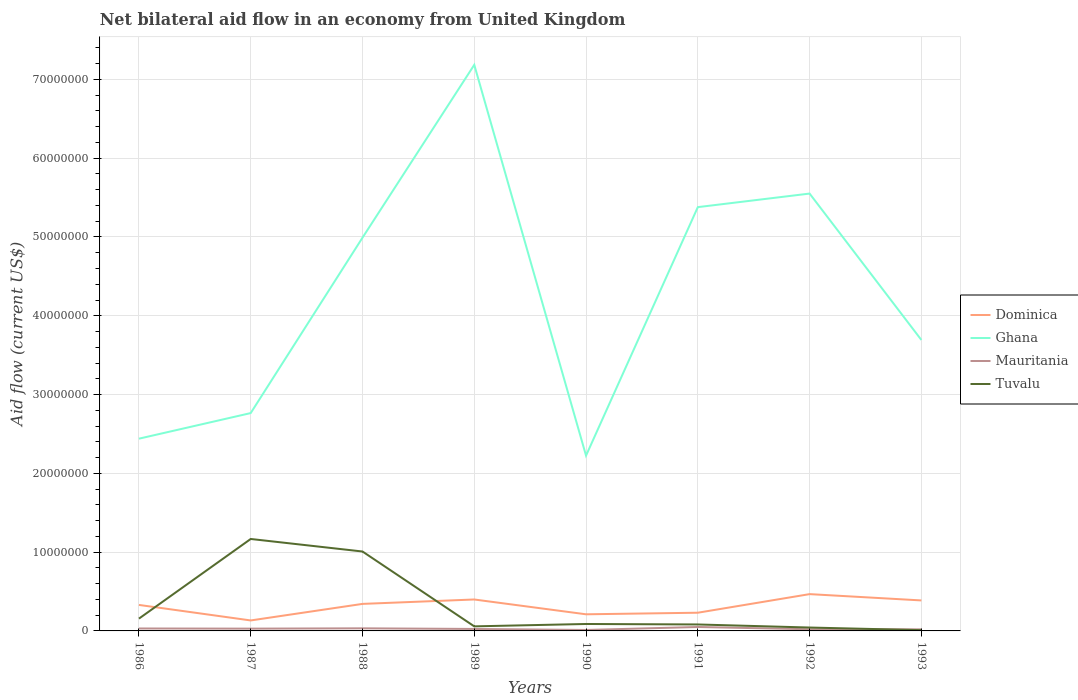Does the line corresponding to Tuvalu intersect with the line corresponding to Mauritania?
Provide a succinct answer. Yes. Is the number of lines equal to the number of legend labels?
Your answer should be very brief. Yes. Across all years, what is the maximum net bilateral aid flow in Tuvalu?
Keep it short and to the point. 1.00e+05. In which year was the net bilateral aid flow in Ghana maximum?
Your response must be concise. 1990. What is the total net bilateral aid flow in Tuvalu in the graph?
Make the answer very short. 7.40e+05. What is the difference between the highest and the second highest net bilateral aid flow in Ghana?
Offer a very short reply. 4.96e+07. Is the net bilateral aid flow in Dominica strictly greater than the net bilateral aid flow in Ghana over the years?
Your answer should be compact. Yes. How many years are there in the graph?
Make the answer very short. 8. What is the difference between two consecutive major ticks on the Y-axis?
Your answer should be very brief. 1.00e+07. Does the graph contain grids?
Make the answer very short. Yes. Where does the legend appear in the graph?
Your response must be concise. Center right. How many legend labels are there?
Make the answer very short. 4. What is the title of the graph?
Your answer should be compact. Net bilateral aid flow in an economy from United Kingdom. What is the label or title of the X-axis?
Your response must be concise. Years. What is the Aid flow (current US$) in Dominica in 1986?
Offer a terse response. 3.30e+06. What is the Aid flow (current US$) of Ghana in 1986?
Offer a terse response. 2.44e+07. What is the Aid flow (current US$) of Tuvalu in 1986?
Make the answer very short. 1.56e+06. What is the Aid flow (current US$) in Dominica in 1987?
Ensure brevity in your answer.  1.33e+06. What is the Aid flow (current US$) in Ghana in 1987?
Give a very brief answer. 2.76e+07. What is the Aid flow (current US$) of Tuvalu in 1987?
Keep it short and to the point. 1.17e+07. What is the Aid flow (current US$) in Dominica in 1988?
Provide a short and direct response. 3.43e+06. What is the Aid flow (current US$) of Ghana in 1988?
Your response must be concise. 4.99e+07. What is the Aid flow (current US$) of Tuvalu in 1988?
Make the answer very short. 1.01e+07. What is the Aid flow (current US$) in Dominica in 1989?
Offer a very short reply. 3.99e+06. What is the Aid flow (current US$) of Ghana in 1989?
Your answer should be very brief. 7.18e+07. What is the Aid flow (current US$) in Tuvalu in 1989?
Your response must be concise. 5.80e+05. What is the Aid flow (current US$) of Dominica in 1990?
Provide a short and direct response. 2.11e+06. What is the Aid flow (current US$) in Ghana in 1990?
Give a very brief answer. 2.22e+07. What is the Aid flow (current US$) of Tuvalu in 1990?
Provide a short and direct response. 8.80e+05. What is the Aid flow (current US$) of Dominica in 1991?
Provide a short and direct response. 2.31e+06. What is the Aid flow (current US$) in Ghana in 1991?
Provide a short and direct response. 5.38e+07. What is the Aid flow (current US$) in Mauritania in 1991?
Give a very brief answer. 5.00e+05. What is the Aid flow (current US$) in Tuvalu in 1991?
Your answer should be very brief. 8.20e+05. What is the Aid flow (current US$) of Dominica in 1992?
Your answer should be compact. 4.67e+06. What is the Aid flow (current US$) of Ghana in 1992?
Offer a terse response. 5.55e+07. What is the Aid flow (current US$) in Tuvalu in 1992?
Provide a short and direct response. 4.30e+05. What is the Aid flow (current US$) of Dominica in 1993?
Provide a short and direct response. 3.87e+06. What is the Aid flow (current US$) in Ghana in 1993?
Make the answer very short. 3.69e+07. Across all years, what is the maximum Aid flow (current US$) in Dominica?
Your answer should be compact. 4.67e+06. Across all years, what is the maximum Aid flow (current US$) in Ghana?
Provide a succinct answer. 7.18e+07. Across all years, what is the maximum Aid flow (current US$) in Tuvalu?
Make the answer very short. 1.17e+07. Across all years, what is the minimum Aid flow (current US$) of Dominica?
Keep it short and to the point. 1.33e+06. Across all years, what is the minimum Aid flow (current US$) of Ghana?
Your answer should be compact. 2.22e+07. What is the total Aid flow (current US$) of Dominica in the graph?
Give a very brief answer. 2.50e+07. What is the total Aid flow (current US$) in Ghana in the graph?
Offer a very short reply. 3.42e+08. What is the total Aid flow (current US$) of Mauritania in the graph?
Your answer should be compact. 2.21e+06. What is the total Aid flow (current US$) in Tuvalu in the graph?
Your answer should be compact. 2.61e+07. What is the difference between the Aid flow (current US$) of Dominica in 1986 and that in 1987?
Your response must be concise. 1.97e+06. What is the difference between the Aid flow (current US$) of Ghana in 1986 and that in 1987?
Give a very brief answer. -3.25e+06. What is the difference between the Aid flow (current US$) in Tuvalu in 1986 and that in 1987?
Give a very brief answer. -1.01e+07. What is the difference between the Aid flow (current US$) of Ghana in 1986 and that in 1988?
Make the answer very short. -2.55e+07. What is the difference between the Aid flow (current US$) of Tuvalu in 1986 and that in 1988?
Make the answer very short. -8.52e+06. What is the difference between the Aid flow (current US$) of Dominica in 1986 and that in 1989?
Ensure brevity in your answer.  -6.90e+05. What is the difference between the Aid flow (current US$) in Ghana in 1986 and that in 1989?
Give a very brief answer. -4.74e+07. What is the difference between the Aid flow (current US$) of Tuvalu in 1986 and that in 1989?
Your answer should be compact. 9.80e+05. What is the difference between the Aid flow (current US$) of Dominica in 1986 and that in 1990?
Make the answer very short. 1.19e+06. What is the difference between the Aid flow (current US$) in Ghana in 1986 and that in 1990?
Your answer should be compact. 2.15e+06. What is the difference between the Aid flow (current US$) in Mauritania in 1986 and that in 1990?
Provide a succinct answer. 1.90e+05. What is the difference between the Aid flow (current US$) in Tuvalu in 1986 and that in 1990?
Offer a very short reply. 6.80e+05. What is the difference between the Aid flow (current US$) of Dominica in 1986 and that in 1991?
Give a very brief answer. 9.90e+05. What is the difference between the Aid flow (current US$) in Ghana in 1986 and that in 1991?
Make the answer very short. -2.94e+07. What is the difference between the Aid flow (current US$) of Tuvalu in 1986 and that in 1991?
Provide a short and direct response. 7.40e+05. What is the difference between the Aid flow (current US$) in Dominica in 1986 and that in 1992?
Keep it short and to the point. -1.37e+06. What is the difference between the Aid flow (current US$) of Ghana in 1986 and that in 1992?
Keep it short and to the point. -3.11e+07. What is the difference between the Aid flow (current US$) in Tuvalu in 1986 and that in 1992?
Offer a very short reply. 1.13e+06. What is the difference between the Aid flow (current US$) in Dominica in 1986 and that in 1993?
Your answer should be compact. -5.70e+05. What is the difference between the Aid flow (current US$) of Ghana in 1986 and that in 1993?
Make the answer very short. -1.25e+07. What is the difference between the Aid flow (current US$) in Tuvalu in 1986 and that in 1993?
Provide a short and direct response. 1.46e+06. What is the difference between the Aid flow (current US$) of Dominica in 1987 and that in 1988?
Give a very brief answer. -2.10e+06. What is the difference between the Aid flow (current US$) of Ghana in 1987 and that in 1988?
Your answer should be very brief. -2.23e+07. What is the difference between the Aid flow (current US$) of Mauritania in 1987 and that in 1988?
Ensure brevity in your answer.  -4.00e+04. What is the difference between the Aid flow (current US$) in Tuvalu in 1987 and that in 1988?
Your answer should be compact. 1.59e+06. What is the difference between the Aid flow (current US$) in Dominica in 1987 and that in 1989?
Offer a terse response. -2.66e+06. What is the difference between the Aid flow (current US$) in Ghana in 1987 and that in 1989?
Keep it short and to the point. -4.42e+07. What is the difference between the Aid flow (current US$) in Mauritania in 1987 and that in 1989?
Keep it short and to the point. 4.00e+04. What is the difference between the Aid flow (current US$) of Tuvalu in 1987 and that in 1989?
Offer a very short reply. 1.11e+07. What is the difference between the Aid flow (current US$) of Dominica in 1987 and that in 1990?
Provide a short and direct response. -7.80e+05. What is the difference between the Aid flow (current US$) in Ghana in 1987 and that in 1990?
Your answer should be compact. 5.40e+06. What is the difference between the Aid flow (current US$) of Mauritania in 1987 and that in 1990?
Ensure brevity in your answer.  1.70e+05. What is the difference between the Aid flow (current US$) in Tuvalu in 1987 and that in 1990?
Provide a short and direct response. 1.08e+07. What is the difference between the Aid flow (current US$) in Dominica in 1987 and that in 1991?
Keep it short and to the point. -9.80e+05. What is the difference between the Aid flow (current US$) in Ghana in 1987 and that in 1991?
Provide a short and direct response. -2.61e+07. What is the difference between the Aid flow (current US$) of Mauritania in 1987 and that in 1991?
Offer a very short reply. -2.10e+05. What is the difference between the Aid flow (current US$) of Tuvalu in 1987 and that in 1991?
Keep it short and to the point. 1.08e+07. What is the difference between the Aid flow (current US$) of Dominica in 1987 and that in 1992?
Give a very brief answer. -3.34e+06. What is the difference between the Aid flow (current US$) of Ghana in 1987 and that in 1992?
Provide a succinct answer. -2.79e+07. What is the difference between the Aid flow (current US$) of Mauritania in 1987 and that in 1992?
Your answer should be compact. 8.00e+04. What is the difference between the Aid flow (current US$) in Tuvalu in 1987 and that in 1992?
Provide a short and direct response. 1.12e+07. What is the difference between the Aid flow (current US$) in Dominica in 1987 and that in 1993?
Your answer should be very brief. -2.54e+06. What is the difference between the Aid flow (current US$) of Ghana in 1987 and that in 1993?
Offer a terse response. -9.28e+06. What is the difference between the Aid flow (current US$) in Tuvalu in 1987 and that in 1993?
Offer a very short reply. 1.16e+07. What is the difference between the Aid flow (current US$) in Dominica in 1988 and that in 1989?
Ensure brevity in your answer.  -5.60e+05. What is the difference between the Aid flow (current US$) of Ghana in 1988 and that in 1989?
Your answer should be compact. -2.19e+07. What is the difference between the Aid flow (current US$) in Tuvalu in 1988 and that in 1989?
Your answer should be compact. 9.50e+06. What is the difference between the Aid flow (current US$) of Dominica in 1988 and that in 1990?
Your response must be concise. 1.32e+06. What is the difference between the Aid flow (current US$) in Ghana in 1988 and that in 1990?
Your response must be concise. 2.77e+07. What is the difference between the Aid flow (current US$) in Tuvalu in 1988 and that in 1990?
Keep it short and to the point. 9.20e+06. What is the difference between the Aid flow (current US$) of Dominica in 1988 and that in 1991?
Keep it short and to the point. 1.12e+06. What is the difference between the Aid flow (current US$) of Ghana in 1988 and that in 1991?
Ensure brevity in your answer.  -3.88e+06. What is the difference between the Aid flow (current US$) in Mauritania in 1988 and that in 1991?
Provide a succinct answer. -1.70e+05. What is the difference between the Aid flow (current US$) of Tuvalu in 1988 and that in 1991?
Provide a succinct answer. 9.26e+06. What is the difference between the Aid flow (current US$) in Dominica in 1988 and that in 1992?
Your answer should be compact. -1.24e+06. What is the difference between the Aid flow (current US$) in Ghana in 1988 and that in 1992?
Your answer should be compact. -5.60e+06. What is the difference between the Aid flow (current US$) in Tuvalu in 1988 and that in 1992?
Provide a short and direct response. 9.65e+06. What is the difference between the Aid flow (current US$) of Dominica in 1988 and that in 1993?
Provide a short and direct response. -4.40e+05. What is the difference between the Aid flow (current US$) in Ghana in 1988 and that in 1993?
Provide a short and direct response. 1.30e+07. What is the difference between the Aid flow (current US$) of Tuvalu in 1988 and that in 1993?
Provide a short and direct response. 9.98e+06. What is the difference between the Aid flow (current US$) in Dominica in 1989 and that in 1990?
Give a very brief answer. 1.88e+06. What is the difference between the Aid flow (current US$) of Ghana in 1989 and that in 1990?
Your answer should be compact. 4.96e+07. What is the difference between the Aid flow (current US$) of Tuvalu in 1989 and that in 1990?
Provide a succinct answer. -3.00e+05. What is the difference between the Aid flow (current US$) in Dominica in 1989 and that in 1991?
Your answer should be compact. 1.68e+06. What is the difference between the Aid flow (current US$) of Ghana in 1989 and that in 1991?
Keep it short and to the point. 1.81e+07. What is the difference between the Aid flow (current US$) in Mauritania in 1989 and that in 1991?
Your answer should be compact. -2.50e+05. What is the difference between the Aid flow (current US$) in Dominica in 1989 and that in 1992?
Keep it short and to the point. -6.80e+05. What is the difference between the Aid flow (current US$) in Ghana in 1989 and that in 1992?
Your answer should be compact. 1.63e+07. What is the difference between the Aid flow (current US$) of Tuvalu in 1989 and that in 1992?
Your answer should be compact. 1.50e+05. What is the difference between the Aid flow (current US$) in Dominica in 1989 and that in 1993?
Ensure brevity in your answer.  1.20e+05. What is the difference between the Aid flow (current US$) of Ghana in 1989 and that in 1993?
Your answer should be compact. 3.49e+07. What is the difference between the Aid flow (current US$) of Mauritania in 1989 and that in 1993?
Give a very brief answer. 5.00e+04. What is the difference between the Aid flow (current US$) in Dominica in 1990 and that in 1991?
Ensure brevity in your answer.  -2.00e+05. What is the difference between the Aid flow (current US$) of Ghana in 1990 and that in 1991?
Make the answer very short. -3.15e+07. What is the difference between the Aid flow (current US$) in Mauritania in 1990 and that in 1991?
Provide a succinct answer. -3.80e+05. What is the difference between the Aid flow (current US$) of Dominica in 1990 and that in 1992?
Keep it short and to the point. -2.56e+06. What is the difference between the Aid flow (current US$) in Ghana in 1990 and that in 1992?
Give a very brief answer. -3.33e+07. What is the difference between the Aid flow (current US$) in Tuvalu in 1990 and that in 1992?
Offer a terse response. 4.50e+05. What is the difference between the Aid flow (current US$) in Dominica in 1990 and that in 1993?
Your answer should be very brief. -1.76e+06. What is the difference between the Aid flow (current US$) in Ghana in 1990 and that in 1993?
Your response must be concise. -1.47e+07. What is the difference between the Aid flow (current US$) of Tuvalu in 1990 and that in 1993?
Your response must be concise. 7.80e+05. What is the difference between the Aid flow (current US$) in Dominica in 1991 and that in 1992?
Your answer should be compact. -2.36e+06. What is the difference between the Aid flow (current US$) in Ghana in 1991 and that in 1992?
Your answer should be very brief. -1.72e+06. What is the difference between the Aid flow (current US$) in Dominica in 1991 and that in 1993?
Your answer should be very brief. -1.56e+06. What is the difference between the Aid flow (current US$) in Ghana in 1991 and that in 1993?
Ensure brevity in your answer.  1.69e+07. What is the difference between the Aid flow (current US$) of Mauritania in 1991 and that in 1993?
Give a very brief answer. 3.00e+05. What is the difference between the Aid flow (current US$) in Tuvalu in 1991 and that in 1993?
Make the answer very short. 7.20e+05. What is the difference between the Aid flow (current US$) of Dominica in 1992 and that in 1993?
Keep it short and to the point. 8.00e+05. What is the difference between the Aid flow (current US$) of Ghana in 1992 and that in 1993?
Offer a terse response. 1.86e+07. What is the difference between the Aid flow (current US$) of Mauritania in 1992 and that in 1993?
Offer a terse response. 10000. What is the difference between the Aid flow (current US$) of Dominica in 1986 and the Aid flow (current US$) of Ghana in 1987?
Offer a terse response. -2.44e+07. What is the difference between the Aid flow (current US$) of Dominica in 1986 and the Aid flow (current US$) of Mauritania in 1987?
Offer a terse response. 3.01e+06. What is the difference between the Aid flow (current US$) in Dominica in 1986 and the Aid flow (current US$) in Tuvalu in 1987?
Keep it short and to the point. -8.37e+06. What is the difference between the Aid flow (current US$) of Ghana in 1986 and the Aid flow (current US$) of Mauritania in 1987?
Your answer should be compact. 2.41e+07. What is the difference between the Aid flow (current US$) of Ghana in 1986 and the Aid flow (current US$) of Tuvalu in 1987?
Provide a succinct answer. 1.27e+07. What is the difference between the Aid flow (current US$) of Mauritania in 1986 and the Aid flow (current US$) of Tuvalu in 1987?
Offer a terse response. -1.14e+07. What is the difference between the Aid flow (current US$) in Dominica in 1986 and the Aid flow (current US$) in Ghana in 1988?
Provide a short and direct response. -4.66e+07. What is the difference between the Aid flow (current US$) of Dominica in 1986 and the Aid flow (current US$) of Mauritania in 1988?
Make the answer very short. 2.97e+06. What is the difference between the Aid flow (current US$) in Dominica in 1986 and the Aid flow (current US$) in Tuvalu in 1988?
Give a very brief answer. -6.78e+06. What is the difference between the Aid flow (current US$) of Ghana in 1986 and the Aid flow (current US$) of Mauritania in 1988?
Provide a short and direct response. 2.41e+07. What is the difference between the Aid flow (current US$) in Ghana in 1986 and the Aid flow (current US$) in Tuvalu in 1988?
Keep it short and to the point. 1.43e+07. What is the difference between the Aid flow (current US$) in Mauritania in 1986 and the Aid flow (current US$) in Tuvalu in 1988?
Your response must be concise. -9.77e+06. What is the difference between the Aid flow (current US$) of Dominica in 1986 and the Aid flow (current US$) of Ghana in 1989?
Your response must be concise. -6.86e+07. What is the difference between the Aid flow (current US$) of Dominica in 1986 and the Aid flow (current US$) of Mauritania in 1989?
Make the answer very short. 3.05e+06. What is the difference between the Aid flow (current US$) in Dominica in 1986 and the Aid flow (current US$) in Tuvalu in 1989?
Provide a short and direct response. 2.72e+06. What is the difference between the Aid flow (current US$) of Ghana in 1986 and the Aid flow (current US$) of Mauritania in 1989?
Keep it short and to the point. 2.42e+07. What is the difference between the Aid flow (current US$) of Ghana in 1986 and the Aid flow (current US$) of Tuvalu in 1989?
Offer a terse response. 2.38e+07. What is the difference between the Aid flow (current US$) in Dominica in 1986 and the Aid flow (current US$) in Ghana in 1990?
Your response must be concise. -1.90e+07. What is the difference between the Aid flow (current US$) of Dominica in 1986 and the Aid flow (current US$) of Mauritania in 1990?
Your response must be concise. 3.18e+06. What is the difference between the Aid flow (current US$) in Dominica in 1986 and the Aid flow (current US$) in Tuvalu in 1990?
Make the answer very short. 2.42e+06. What is the difference between the Aid flow (current US$) of Ghana in 1986 and the Aid flow (current US$) of Mauritania in 1990?
Give a very brief answer. 2.43e+07. What is the difference between the Aid flow (current US$) of Ghana in 1986 and the Aid flow (current US$) of Tuvalu in 1990?
Give a very brief answer. 2.35e+07. What is the difference between the Aid flow (current US$) in Mauritania in 1986 and the Aid flow (current US$) in Tuvalu in 1990?
Offer a terse response. -5.70e+05. What is the difference between the Aid flow (current US$) of Dominica in 1986 and the Aid flow (current US$) of Ghana in 1991?
Offer a very short reply. -5.05e+07. What is the difference between the Aid flow (current US$) in Dominica in 1986 and the Aid flow (current US$) in Mauritania in 1991?
Your response must be concise. 2.80e+06. What is the difference between the Aid flow (current US$) of Dominica in 1986 and the Aid flow (current US$) of Tuvalu in 1991?
Your answer should be compact. 2.48e+06. What is the difference between the Aid flow (current US$) of Ghana in 1986 and the Aid flow (current US$) of Mauritania in 1991?
Make the answer very short. 2.39e+07. What is the difference between the Aid flow (current US$) in Ghana in 1986 and the Aid flow (current US$) in Tuvalu in 1991?
Provide a short and direct response. 2.36e+07. What is the difference between the Aid flow (current US$) of Mauritania in 1986 and the Aid flow (current US$) of Tuvalu in 1991?
Keep it short and to the point. -5.10e+05. What is the difference between the Aid flow (current US$) of Dominica in 1986 and the Aid flow (current US$) of Ghana in 1992?
Offer a terse response. -5.22e+07. What is the difference between the Aid flow (current US$) in Dominica in 1986 and the Aid flow (current US$) in Mauritania in 1992?
Give a very brief answer. 3.09e+06. What is the difference between the Aid flow (current US$) in Dominica in 1986 and the Aid flow (current US$) in Tuvalu in 1992?
Provide a short and direct response. 2.87e+06. What is the difference between the Aid flow (current US$) of Ghana in 1986 and the Aid flow (current US$) of Mauritania in 1992?
Offer a very short reply. 2.42e+07. What is the difference between the Aid flow (current US$) of Ghana in 1986 and the Aid flow (current US$) of Tuvalu in 1992?
Your response must be concise. 2.40e+07. What is the difference between the Aid flow (current US$) in Mauritania in 1986 and the Aid flow (current US$) in Tuvalu in 1992?
Make the answer very short. -1.20e+05. What is the difference between the Aid flow (current US$) of Dominica in 1986 and the Aid flow (current US$) of Ghana in 1993?
Provide a succinct answer. -3.36e+07. What is the difference between the Aid flow (current US$) of Dominica in 1986 and the Aid flow (current US$) of Mauritania in 1993?
Make the answer very short. 3.10e+06. What is the difference between the Aid flow (current US$) in Dominica in 1986 and the Aid flow (current US$) in Tuvalu in 1993?
Provide a succinct answer. 3.20e+06. What is the difference between the Aid flow (current US$) in Ghana in 1986 and the Aid flow (current US$) in Mauritania in 1993?
Offer a terse response. 2.42e+07. What is the difference between the Aid flow (current US$) in Ghana in 1986 and the Aid flow (current US$) in Tuvalu in 1993?
Keep it short and to the point. 2.43e+07. What is the difference between the Aid flow (current US$) in Dominica in 1987 and the Aid flow (current US$) in Ghana in 1988?
Offer a very short reply. -4.86e+07. What is the difference between the Aid flow (current US$) of Dominica in 1987 and the Aid flow (current US$) of Mauritania in 1988?
Your answer should be compact. 1.00e+06. What is the difference between the Aid flow (current US$) of Dominica in 1987 and the Aid flow (current US$) of Tuvalu in 1988?
Your response must be concise. -8.75e+06. What is the difference between the Aid flow (current US$) of Ghana in 1987 and the Aid flow (current US$) of Mauritania in 1988?
Make the answer very short. 2.73e+07. What is the difference between the Aid flow (current US$) in Ghana in 1987 and the Aid flow (current US$) in Tuvalu in 1988?
Your answer should be compact. 1.76e+07. What is the difference between the Aid flow (current US$) of Mauritania in 1987 and the Aid flow (current US$) of Tuvalu in 1988?
Your response must be concise. -9.79e+06. What is the difference between the Aid flow (current US$) of Dominica in 1987 and the Aid flow (current US$) of Ghana in 1989?
Offer a terse response. -7.05e+07. What is the difference between the Aid flow (current US$) in Dominica in 1987 and the Aid flow (current US$) in Mauritania in 1989?
Your response must be concise. 1.08e+06. What is the difference between the Aid flow (current US$) of Dominica in 1987 and the Aid flow (current US$) of Tuvalu in 1989?
Keep it short and to the point. 7.50e+05. What is the difference between the Aid flow (current US$) in Ghana in 1987 and the Aid flow (current US$) in Mauritania in 1989?
Your answer should be very brief. 2.74e+07. What is the difference between the Aid flow (current US$) in Ghana in 1987 and the Aid flow (current US$) in Tuvalu in 1989?
Make the answer very short. 2.71e+07. What is the difference between the Aid flow (current US$) of Dominica in 1987 and the Aid flow (current US$) of Ghana in 1990?
Your answer should be compact. -2.09e+07. What is the difference between the Aid flow (current US$) in Dominica in 1987 and the Aid flow (current US$) in Mauritania in 1990?
Provide a succinct answer. 1.21e+06. What is the difference between the Aid flow (current US$) in Ghana in 1987 and the Aid flow (current US$) in Mauritania in 1990?
Offer a very short reply. 2.75e+07. What is the difference between the Aid flow (current US$) of Ghana in 1987 and the Aid flow (current US$) of Tuvalu in 1990?
Provide a short and direct response. 2.68e+07. What is the difference between the Aid flow (current US$) of Mauritania in 1987 and the Aid flow (current US$) of Tuvalu in 1990?
Your answer should be very brief. -5.90e+05. What is the difference between the Aid flow (current US$) in Dominica in 1987 and the Aid flow (current US$) in Ghana in 1991?
Offer a very short reply. -5.25e+07. What is the difference between the Aid flow (current US$) in Dominica in 1987 and the Aid flow (current US$) in Mauritania in 1991?
Your answer should be compact. 8.30e+05. What is the difference between the Aid flow (current US$) of Dominica in 1987 and the Aid flow (current US$) of Tuvalu in 1991?
Provide a short and direct response. 5.10e+05. What is the difference between the Aid flow (current US$) in Ghana in 1987 and the Aid flow (current US$) in Mauritania in 1991?
Provide a short and direct response. 2.72e+07. What is the difference between the Aid flow (current US$) in Ghana in 1987 and the Aid flow (current US$) in Tuvalu in 1991?
Your answer should be compact. 2.68e+07. What is the difference between the Aid flow (current US$) in Mauritania in 1987 and the Aid flow (current US$) in Tuvalu in 1991?
Give a very brief answer. -5.30e+05. What is the difference between the Aid flow (current US$) of Dominica in 1987 and the Aid flow (current US$) of Ghana in 1992?
Offer a very short reply. -5.42e+07. What is the difference between the Aid flow (current US$) in Dominica in 1987 and the Aid flow (current US$) in Mauritania in 1992?
Your response must be concise. 1.12e+06. What is the difference between the Aid flow (current US$) in Ghana in 1987 and the Aid flow (current US$) in Mauritania in 1992?
Keep it short and to the point. 2.74e+07. What is the difference between the Aid flow (current US$) in Ghana in 1987 and the Aid flow (current US$) in Tuvalu in 1992?
Your answer should be compact. 2.72e+07. What is the difference between the Aid flow (current US$) in Dominica in 1987 and the Aid flow (current US$) in Ghana in 1993?
Ensure brevity in your answer.  -3.56e+07. What is the difference between the Aid flow (current US$) in Dominica in 1987 and the Aid flow (current US$) in Mauritania in 1993?
Provide a short and direct response. 1.13e+06. What is the difference between the Aid flow (current US$) of Dominica in 1987 and the Aid flow (current US$) of Tuvalu in 1993?
Provide a succinct answer. 1.23e+06. What is the difference between the Aid flow (current US$) of Ghana in 1987 and the Aid flow (current US$) of Mauritania in 1993?
Provide a short and direct response. 2.74e+07. What is the difference between the Aid flow (current US$) of Ghana in 1987 and the Aid flow (current US$) of Tuvalu in 1993?
Your answer should be very brief. 2.76e+07. What is the difference between the Aid flow (current US$) in Mauritania in 1987 and the Aid flow (current US$) in Tuvalu in 1993?
Ensure brevity in your answer.  1.90e+05. What is the difference between the Aid flow (current US$) in Dominica in 1988 and the Aid flow (current US$) in Ghana in 1989?
Your answer should be very brief. -6.84e+07. What is the difference between the Aid flow (current US$) in Dominica in 1988 and the Aid flow (current US$) in Mauritania in 1989?
Provide a succinct answer. 3.18e+06. What is the difference between the Aid flow (current US$) of Dominica in 1988 and the Aid flow (current US$) of Tuvalu in 1989?
Make the answer very short. 2.85e+06. What is the difference between the Aid flow (current US$) of Ghana in 1988 and the Aid flow (current US$) of Mauritania in 1989?
Your answer should be very brief. 4.97e+07. What is the difference between the Aid flow (current US$) of Ghana in 1988 and the Aid flow (current US$) of Tuvalu in 1989?
Provide a short and direct response. 4.93e+07. What is the difference between the Aid flow (current US$) of Mauritania in 1988 and the Aid flow (current US$) of Tuvalu in 1989?
Ensure brevity in your answer.  -2.50e+05. What is the difference between the Aid flow (current US$) in Dominica in 1988 and the Aid flow (current US$) in Ghana in 1990?
Ensure brevity in your answer.  -1.88e+07. What is the difference between the Aid flow (current US$) of Dominica in 1988 and the Aid flow (current US$) of Mauritania in 1990?
Offer a very short reply. 3.31e+06. What is the difference between the Aid flow (current US$) in Dominica in 1988 and the Aid flow (current US$) in Tuvalu in 1990?
Provide a short and direct response. 2.55e+06. What is the difference between the Aid flow (current US$) of Ghana in 1988 and the Aid flow (current US$) of Mauritania in 1990?
Make the answer very short. 4.98e+07. What is the difference between the Aid flow (current US$) of Ghana in 1988 and the Aid flow (current US$) of Tuvalu in 1990?
Offer a terse response. 4.90e+07. What is the difference between the Aid flow (current US$) of Mauritania in 1988 and the Aid flow (current US$) of Tuvalu in 1990?
Give a very brief answer. -5.50e+05. What is the difference between the Aid flow (current US$) in Dominica in 1988 and the Aid flow (current US$) in Ghana in 1991?
Give a very brief answer. -5.04e+07. What is the difference between the Aid flow (current US$) in Dominica in 1988 and the Aid flow (current US$) in Mauritania in 1991?
Offer a terse response. 2.93e+06. What is the difference between the Aid flow (current US$) in Dominica in 1988 and the Aid flow (current US$) in Tuvalu in 1991?
Offer a very short reply. 2.61e+06. What is the difference between the Aid flow (current US$) in Ghana in 1988 and the Aid flow (current US$) in Mauritania in 1991?
Ensure brevity in your answer.  4.94e+07. What is the difference between the Aid flow (current US$) in Ghana in 1988 and the Aid flow (current US$) in Tuvalu in 1991?
Keep it short and to the point. 4.91e+07. What is the difference between the Aid flow (current US$) in Mauritania in 1988 and the Aid flow (current US$) in Tuvalu in 1991?
Your answer should be very brief. -4.90e+05. What is the difference between the Aid flow (current US$) in Dominica in 1988 and the Aid flow (current US$) in Ghana in 1992?
Offer a very short reply. -5.21e+07. What is the difference between the Aid flow (current US$) in Dominica in 1988 and the Aid flow (current US$) in Mauritania in 1992?
Offer a terse response. 3.22e+06. What is the difference between the Aid flow (current US$) in Ghana in 1988 and the Aid flow (current US$) in Mauritania in 1992?
Keep it short and to the point. 4.97e+07. What is the difference between the Aid flow (current US$) of Ghana in 1988 and the Aid flow (current US$) of Tuvalu in 1992?
Offer a very short reply. 4.95e+07. What is the difference between the Aid flow (current US$) in Dominica in 1988 and the Aid flow (current US$) in Ghana in 1993?
Keep it short and to the point. -3.35e+07. What is the difference between the Aid flow (current US$) of Dominica in 1988 and the Aid flow (current US$) of Mauritania in 1993?
Provide a short and direct response. 3.23e+06. What is the difference between the Aid flow (current US$) in Dominica in 1988 and the Aid flow (current US$) in Tuvalu in 1993?
Offer a very short reply. 3.33e+06. What is the difference between the Aid flow (current US$) of Ghana in 1988 and the Aid flow (current US$) of Mauritania in 1993?
Keep it short and to the point. 4.97e+07. What is the difference between the Aid flow (current US$) in Ghana in 1988 and the Aid flow (current US$) in Tuvalu in 1993?
Offer a terse response. 4.98e+07. What is the difference between the Aid flow (current US$) of Mauritania in 1988 and the Aid flow (current US$) of Tuvalu in 1993?
Give a very brief answer. 2.30e+05. What is the difference between the Aid flow (current US$) in Dominica in 1989 and the Aid flow (current US$) in Ghana in 1990?
Make the answer very short. -1.83e+07. What is the difference between the Aid flow (current US$) in Dominica in 1989 and the Aid flow (current US$) in Mauritania in 1990?
Your response must be concise. 3.87e+06. What is the difference between the Aid flow (current US$) in Dominica in 1989 and the Aid flow (current US$) in Tuvalu in 1990?
Keep it short and to the point. 3.11e+06. What is the difference between the Aid flow (current US$) in Ghana in 1989 and the Aid flow (current US$) in Mauritania in 1990?
Make the answer very short. 7.17e+07. What is the difference between the Aid flow (current US$) of Ghana in 1989 and the Aid flow (current US$) of Tuvalu in 1990?
Offer a terse response. 7.10e+07. What is the difference between the Aid flow (current US$) in Mauritania in 1989 and the Aid flow (current US$) in Tuvalu in 1990?
Make the answer very short. -6.30e+05. What is the difference between the Aid flow (current US$) of Dominica in 1989 and the Aid flow (current US$) of Ghana in 1991?
Offer a very short reply. -4.98e+07. What is the difference between the Aid flow (current US$) in Dominica in 1989 and the Aid flow (current US$) in Mauritania in 1991?
Offer a terse response. 3.49e+06. What is the difference between the Aid flow (current US$) in Dominica in 1989 and the Aid flow (current US$) in Tuvalu in 1991?
Provide a succinct answer. 3.17e+06. What is the difference between the Aid flow (current US$) of Ghana in 1989 and the Aid flow (current US$) of Mauritania in 1991?
Offer a very short reply. 7.14e+07. What is the difference between the Aid flow (current US$) in Ghana in 1989 and the Aid flow (current US$) in Tuvalu in 1991?
Your answer should be very brief. 7.10e+07. What is the difference between the Aid flow (current US$) of Mauritania in 1989 and the Aid flow (current US$) of Tuvalu in 1991?
Offer a very short reply. -5.70e+05. What is the difference between the Aid flow (current US$) of Dominica in 1989 and the Aid flow (current US$) of Ghana in 1992?
Your answer should be compact. -5.15e+07. What is the difference between the Aid flow (current US$) of Dominica in 1989 and the Aid flow (current US$) of Mauritania in 1992?
Keep it short and to the point. 3.78e+06. What is the difference between the Aid flow (current US$) in Dominica in 1989 and the Aid flow (current US$) in Tuvalu in 1992?
Your answer should be compact. 3.56e+06. What is the difference between the Aid flow (current US$) of Ghana in 1989 and the Aid flow (current US$) of Mauritania in 1992?
Offer a very short reply. 7.16e+07. What is the difference between the Aid flow (current US$) in Ghana in 1989 and the Aid flow (current US$) in Tuvalu in 1992?
Provide a succinct answer. 7.14e+07. What is the difference between the Aid flow (current US$) in Dominica in 1989 and the Aid flow (current US$) in Ghana in 1993?
Your answer should be very brief. -3.29e+07. What is the difference between the Aid flow (current US$) of Dominica in 1989 and the Aid flow (current US$) of Mauritania in 1993?
Your answer should be compact. 3.79e+06. What is the difference between the Aid flow (current US$) in Dominica in 1989 and the Aid flow (current US$) in Tuvalu in 1993?
Your response must be concise. 3.89e+06. What is the difference between the Aid flow (current US$) in Ghana in 1989 and the Aid flow (current US$) in Mauritania in 1993?
Keep it short and to the point. 7.16e+07. What is the difference between the Aid flow (current US$) in Ghana in 1989 and the Aid flow (current US$) in Tuvalu in 1993?
Give a very brief answer. 7.18e+07. What is the difference between the Aid flow (current US$) in Dominica in 1990 and the Aid flow (current US$) in Ghana in 1991?
Provide a short and direct response. -5.17e+07. What is the difference between the Aid flow (current US$) of Dominica in 1990 and the Aid flow (current US$) of Mauritania in 1991?
Provide a short and direct response. 1.61e+06. What is the difference between the Aid flow (current US$) of Dominica in 1990 and the Aid flow (current US$) of Tuvalu in 1991?
Offer a very short reply. 1.29e+06. What is the difference between the Aid flow (current US$) of Ghana in 1990 and the Aid flow (current US$) of Mauritania in 1991?
Offer a terse response. 2.18e+07. What is the difference between the Aid flow (current US$) in Ghana in 1990 and the Aid flow (current US$) in Tuvalu in 1991?
Your answer should be compact. 2.14e+07. What is the difference between the Aid flow (current US$) of Mauritania in 1990 and the Aid flow (current US$) of Tuvalu in 1991?
Provide a succinct answer. -7.00e+05. What is the difference between the Aid flow (current US$) in Dominica in 1990 and the Aid flow (current US$) in Ghana in 1992?
Offer a very short reply. -5.34e+07. What is the difference between the Aid flow (current US$) in Dominica in 1990 and the Aid flow (current US$) in Mauritania in 1992?
Ensure brevity in your answer.  1.90e+06. What is the difference between the Aid flow (current US$) in Dominica in 1990 and the Aid flow (current US$) in Tuvalu in 1992?
Your answer should be compact. 1.68e+06. What is the difference between the Aid flow (current US$) of Ghana in 1990 and the Aid flow (current US$) of Mauritania in 1992?
Ensure brevity in your answer.  2.20e+07. What is the difference between the Aid flow (current US$) of Ghana in 1990 and the Aid flow (current US$) of Tuvalu in 1992?
Offer a terse response. 2.18e+07. What is the difference between the Aid flow (current US$) of Mauritania in 1990 and the Aid flow (current US$) of Tuvalu in 1992?
Ensure brevity in your answer.  -3.10e+05. What is the difference between the Aid flow (current US$) in Dominica in 1990 and the Aid flow (current US$) in Ghana in 1993?
Ensure brevity in your answer.  -3.48e+07. What is the difference between the Aid flow (current US$) of Dominica in 1990 and the Aid flow (current US$) of Mauritania in 1993?
Give a very brief answer. 1.91e+06. What is the difference between the Aid flow (current US$) of Dominica in 1990 and the Aid flow (current US$) of Tuvalu in 1993?
Offer a very short reply. 2.01e+06. What is the difference between the Aid flow (current US$) of Ghana in 1990 and the Aid flow (current US$) of Mauritania in 1993?
Provide a short and direct response. 2.20e+07. What is the difference between the Aid flow (current US$) in Ghana in 1990 and the Aid flow (current US$) in Tuvalu in 1993?
Your answer should be compact. 2.22e+07. What is the difference between the Aid flow (current US$) of Dominica in 1991 and the Aid flow (current US$) of Ghana in 1992?
Make the answer very short. -5.32e+07. What is the difference between the Aid flow (current US$) of Dominica in 1991 and the Aid flow (current US$) of Mauritania in 1992?
Your response must be concise. 2.10e+06. What is the difference between the Aid flow (current US$) of Dominica in 1991 and the Aid flow (current US$) of Tuvalu in 1992?
Provide a succinct answer. 1.88e+06. What is the difference between the Aid flow (current US$) in Ghana in 1991 and the Aid flow (current US$) in Mauritania in 1992?
Your answer should be very brief. 5.36e+07. What is the difference between the Aid flow (current US$) in Ghana in 1991 and the Aid flow (current US$) in Tuvalu in 1992?
Give a very brief answer. 5.34e+07. What is the difference between the Aid flow (current US$) in Mauritania in 1991 and the Aid flow (current US$) in Tuvalu in 1992?
Ensure brevity in your answer.  7.00e+04. What is the difference between the Aid flow (current US$) in Dominica in 1991 and the Aid flow (current US$) in Ghana in 1993?
Provide a short and direct response. -3.46e+07. What is the difference between the Aid flow (current US$) in Dominica in 1991 and the Aid flow (current US$) in Mauritania in 1993?
Your response must be concise. 2.11e+06. What is the difference between the Aid flow (current US$) in Dominica in 1991 and the Aid flow (current US$) in Tuvalu in 1993?
Your answer should be very brief. 2.21e+06. What is the difference between the Aid flow (current US$) in Ghana in 1991 and the Aid flow (current US$) in Mauritania in 1993?
Provide a short and direct response. 5.36e+07. What is the difference between the Aid flow (current US$) in Ghana in 1991 and the Aid flow (current US$) in Tuvalu in 1993?
Provide a succinct answer. 5.37e+07. What is the difference between the Aid flow (current US$) of Dominica in 1992 and the Aid flow (current US$) of Ghana in 1993?
Ensure brevity in your answer.  -3.23e+07. What is the difference between the Aid flow (current US$) in Dominica in 1992 and the Aid flow (current US$) in Mauritania in 1993?
Offer a terse response. 4.47e+06. What is the difference between the Aid flow (current US$) of Dominica in 1992 and the Aid flow (current US$) of Tuvalu in 1993?
Your response must be concise. 4.57e+06. What is the difference between the Aid flow (current US$) in Ghana in 1992 and the Aid flow (current US$) in Mauritania in 1993?
Your answer should be compact. 5.53e+07. What is the difference between the Aid flow (current US$) of Ghana in 1992 and the Aid flow (current US$) of Tuvalu in 1993?
Provide a succinct answer. 5.54e+07. What is the difference between the Aid flow (current US$) in Mauritania in 1992 and the Aid flow (current US$) in Tuvalu in 1993?
Provide a short and direct response. 1.10e+05. What is the average Aid flow (current US$) in Dominica per year?
Offer a terse response. 3.13e+06. What is the average Aid flow (current US$) in Ghana per year?
Offer a terse response. 4.28e+07. What is the average Aid flow (current US$) in Mauritania per year?
Provide a succinct answer. 2.76e+05. What is the average Aid flow (current US$) in Tuvalu per year?
Provide a succinct answer. 3.26e+06. In the year 1986, what is the difference between the Aid flow (current US$) in Dominica and Aid flow (current US$) in Ghana?
Your answer should be compact. -2.11e+07. In the year 1986, what is the difference between the Aid flow (current US$) of Dominica and Aid flow (current US$) of Mauritania?
Give a very brief answer. 2.99e+06. In the year 1986, what is the difference between the Aid flow (current US$) of Dominica and Aid flow (current US$) of Tuvalu?
Give a very brief answer. 1.74e+06. In the year 1986, what is the difference between the Aid flow (current US$) of Ghana and Aid flow (current US$) of Mauritania?
Your response must be concise. 2.41e+07. In the year 1986, what is the difference between the Aid flow (current US$) of Ghana and Aid flow (current US$) of Tuvalu?
Your response must be concise. 2.28e+07. In the year 1986, what is the difference between the Aid flow (current US$) of Mauritania and Aid flow (current US$) of Tuvalu?
Provide a succinct answer. -1.25e+06. In the year 1987, what is the difference between the Aid flow (current US$) of Dominica and Aid flow (current US$) of Ghana?
Your response must be concise. -2.63e+07. In the year 1987, what is the difference between the Aid flow (current US$) of Dominica and Aid flow (current US$) of Mauritania?
Offer a terse response. 1.04e+06. In the year 1987, what is the difference between the Aid flow (current US$) in Dominica and Aid flow (current US$) in Tuvalu?
Your response must be concise. -1.03e+07. In the year 1987, what is the difference between the Aid flow (current US$) in Ghana and Aid flow (current US$) in Mauritania?
Your answer should be compact. 2.74e+07. In the year 1987, what is the difference between the Aid flow (current US$) of Ghana and Aid flow (current US$) of Tuvalu?
Your answer should be very brief. 1.60e+07. In the year 1987, what is the difference between the Aid flow (current US$) in Mauritania and Aid flow (current US$) in Tuvalu?
Provide a succinct answer. -1.14e+07. In the year 1988, what is the difference between the Aid flow (current US$) in Dominica and Aid flow (current US$) in Ghana?
Provide a short and direct response. -4.65e+07. In the year 1988, what is the difference between the Aid flow (current US$) in Dominica and Aid flow (current US$) in Mauritania?
Make the answer very short. 3.10e+06. In the year 1988, what is the difference between the Aid flow (current US$) of Dominica and Aid flow (current US$) of Tuvalu?
Provide a succinct answer. -6.65e+06. In the year 1988, what is the difference between the Aid flow (current US$) in Ghana and Aid flow (current US$) in Mauritania?
Offer a terse response. 4.96e+07. In the year 1988, what is the difference between the Aid flow (current US$) in Ghana and Aid flow (current US$) in Tuvalu?
Keep it short and to the point. 3.98e+07. In the year 1988, what is the difference between the Aid flow (current US$) in Mauritania and Aid flow (current US$) in Tuvalu?
Offer a very short reply. -9.75e+06. In the year 1989, what is the difference between the Aid flow (current US$) in Dominica and Aid flow (current US$) in Ghana?
Your answer should be compact. -6.79e+07. In the year 1989, what is the difference between the Aid flow (current US$) of Dominica and Aid flow (current US$) of Mauritania?
Provide a succinct answer. 3.74e+06. In the year 1989, what is the difference between the Aid flow (current US$) in Dominica and Aid flow (current US$) in Tuvalu?
Make the answer very short. 3.41e+06. In the year 1989, what is the difference between the Aid flow (current US$) of Ghana and Aid flow (current US$) of Mauritania?
Provide a succinct answer. 7.16e+07. In the year 1989, what is the difference between the Aid flow (current US$) of Ghana and Aid flow (current US$) of Tuvalu?
Give a very brief answer. 7.13e+07. In the year 1989, what is the difference between the Aid flow (current US$) of Mauritania and Aid flow (current US$) of Tuvalu?
Ensure brevity in your answer.  -3.30e+05. In the year 1990, what is the difference between the Aid flow (current US$) of Dominica and Aid flow (current US$) of Ghana?
Provide a short and direct response. -2.01e+07. In the year 1990, what is the difference between the Aid flow (current US$) in Dominica and Aid flow (current US$) in Mauritania?
Your answer should be compact. 1.99e+06. In the year 1990, what is the difference between the Aid flow (current US$) of Dominica and Aid flow (current US$) of Tuvalu?
Keep it short and to the point. 1.23e+06. In the year 1990, what is the difference between the Aid flow (current US$) in Ghana and Aid flow (current US$) in Mauritania?
Provide a succinct answer. 2.21e+07. In the year 1990, what is the difference between the Aid flow (current US$) in Ghana and Aid flow (current US$) in Tuvalu?
Offer a terse response. 2.14e+07. In the year 1990, what is the difference between the Aid flow (current US$) of Mauritania and Aid flow (current US$) of Tuvalu?
Offer a terse response. -7.60e+05. In the year 1991, what is the difference between the Aid flow (current US$) in Dominica and Aid flow (current US$) in Ghana?
Offer a very short reply. -5.15e+07. In the year 1991, what is the difference between the Aid flow (current US$) of Dominica and Aid flow (current US$) of Mauritania?
Keep it short and to the point. 1.81e+06. In the year 1991, what is the difference between the Aid flow (current US$) of Dominica and Aid flow (current US$) of Tuvalu?
Your response must be concise. 1.49e+06. In the year 1991, what is the difference between the Aid flow (current US$) in Ghana and Aid flow (current US$) in Mauritania?
Make the answer very short. 5.33e+07. In the year 1991, what is the difference between the Aid flow (current US$) of Ghana and Aid flow (current US$) of Tuvalu?
Provide a succinct answer. 5.30e+07. In the year 1991, what is the difference between the Aid flow (current US$) of Mauritania and Aid flow (current US$) of Tuvalu?
Provide a succinct answer. -3.20e+05. In the year 1992, what is the difference between the Aid flow (current US$) in Dominica and Aid flow (current US$) in Ghana?
Your answer should be compact. -5.08e+07. In the year 1992, what is the difference between the Aid flow (current US$) of Dominica and Aid flow (current US$) of Mauritania?
Ensure brevity in your answer.  4.46e+06. In the year 1992, what is the difference between the Aid flow (current US$) of Dominica and Aid flow (current US$) of Tuvalu?
Make the answer very short. 4.24e+06. In the year 1992, what is the difference between the Aid flow (current US$) of Ghana and Aid flow (current US$) of Mauritania?
Your answer should be compact. 5.53e+07. In the year 1992, what is the difference between the Aid flow (current US$) in Ghana and Aid flow (current US$) in Tuvalu?
Keep it short and to the point. 5.51e+07. In the year 1993, what is the difference between the Aid flow (current US$) in Dominica and Aid flow (current US$) in Ghana?
Your response must be concise. -3.31e+07. In the year 1993, what is the difference between the Aid flow (current US$) in Dominica and Aid flow (current US$) in Mauritania?
Your response must be concise. 3.67e+06. In the year 1993, what is the difference between the Aid flow (current US$) of Dominica and Aid flow (current US$) of Tuvalu?
Provide a short and direct response. 3.77e+06. In the year 1993, what is the difference between the Aid flow (current US$) in Ghana and Aid flow (current US$) in Mauritania?
Offer a terse response. 3.67e+07. In the year 1993, what is the difference between the Aid flow (current US$) in Ghana and Aid flow (current US$) in Tuvalu?
Ensure brevity in your answer.  3.68e+07. What is the ratio of the Aid flow (current US$) in Dominica in 1986 to that in 1987?
Make the answer very short. 2.48. What is the ratio of the Aid flow (current US$) in Ghana in 1986 to that in 1987?
Keep it short and to the point. 0.88. What is the ratio of the Aid flow (current US$) in Mauritania in 1986 to that in 1987?
Your response must be concise. 1.07. What is the ratio of the Aid flow (current US$) in Tuvalu in 1986 to that in 1987?
Your answer should be compact. 0.13. What is the ratio of the Aid flow (current US$) in Dominica in 1986 to that in 1988?
Keep it short and to the point. 0.96. What is the ratio of the Aid flow (current US$) of Ghana in 1986 to that in 1988?
Provide a short and direct response. 0.49. What is the ratio of the Aid flow (current US$) of Mauritania in 1986 to that in 1988?
Provide a short and direct response. 0.94. What is the ratio of the Aid flow (current US$) of Tuvalu in 1986 to that in 1988?
Give a very brief answer. 0.15. What is the ratio of the Aid flow (current US$) in Dominica in 1986 to that in 1989?
Give a very brief answer. 0.83. What is the ratio of the Aid flow (current US$) in Ghana in 1986 to that in 1989?
Your answer should be compact. 0.34. What is the ratio of the Aid flow (current US$) of Mauritania in 1986 to that in 1989?
Provide a short and direct response. 1.24. What is the ratio of the Aid flow (current US$) in Tuvalu in 1986 to that in 1989?
Make the answer very short. 2.69. What is the ratio of the Aid flow (current US$) of Dominica in 1986 to that in 1990?
Offer a terse response. 1.56. What is the ratio of the Aid flow (current US$) in Ghana in 1986 to that in 1990?
Keep it short and to the point. 1.1. What is the ratio of the Aid flow (current US$) in Mauritania in 1986 to that in 1990?
Give a very brief answer. 2.58. What is the ratio of the Aid flow (current US$) in Tuvalu in 1986 to that in 1990?
Your answer should be very brief. 1.77. What is the ratio of the Aid flow (current US$) in Dominica in 1986 to that in 1991?
Provide a succinct answer. 1.43. What is the ratio of the Aid flow (current US$) in Ghana in 1986 to that in 1991?
Make the answer very short. 0.45. What is the ratio of the Aid flow (current US$) in Mauritania in 1986 to that in 1991?
Your answer should be compact. 0.62. What is the ratio of the Aid flow (current US$) of Tuvalu in 1986 to that in 1991?
Make the answer very short. 1.9. What is the ratio of the Aid flow (current US$) in Dominica in 1986 to that in 1992?
Your answer should be very brief. 0.71. What is the ratio of the Aid flow (current US$) of Ghana in 1986 to that in 1992?
Give a very brief answer. 0.44. What is the ratio of the Aid flow (current US$) of Mauritania in 1986 to that in 1992?
Provide a succinct answer. 1.48. What is the ratio of the Aid flow (current US$) of Tuvalu in 1986 to that in 1992?
Provide a short and direct response. 3.63. What is the ratio of the Aid flow (current US$) in Dominica in 1986 to that in 1993?
Give a very brief answer. 0.85. What is the ratio of the Aid flow (current US$) of Ghana in 1986 to that in 1993?
Keep it short and to the point. 0.66. What is the ratio of the Aid flow (current US$) of Mauritania in 1986 to that in 1993?
Provide a short and direct response. 1.55. What is the ratio of the Aid flow (current US$) of Tuvalu in 1986 to that in 1993?
Offer a terse response. 15.6. What is the ratio of the Aid flow (current US$) in Dominica in 1987 to that in 1988?
Provide a succinct answer. 0.39. What is the ratio of the Aid flow (current US$) of Ghana in 1987 to that in 1988?
Your answer should be very brief. 0.55. What is the ratio of the Aid flow (current US$) of Mauritania in 1987 to that in 1988?
Offer a very short reply. 0.88. What is the ratio of the Aid flow (current US$) in Tuvalu in 1987 to that in 1988?
Your answer should be compact. 1.16. What is the ratio of the Aid flow (current US$) in Dominica in 1987 to that in 1989?
Keep it short and to the point. 0.33. What is the ratio of the Aid flow (current US$) in Ghana in 1987 to that in 1989?
Give a very brief answer. 0.38. What is the ratio of the Aid flow (current US$) in Mauritania in 1987 to that in 1989?
Your answer should be very brief. 1.16. What is the ratio of the Aid flow (current US$) in Tuvalu in 1987 to that in 1989?
Your response must be concise. 20.12. What is the ratio of the Aid flow (current US$) in Dominica in 1987 to that in 1990?
Provide a succinct answer. 0.63. What is the ratio of the Aid flow (current US$) of Ghana in 1987 to that in 1990?
Provide a short and direct response. 1.24. What is the ratio of the Aid flow (current US$) in Mauritania in 1987 to that in 1990?
Provide a succinct answer. 2.42. What is the ratio of the Aid flow (current US$) of Tuvalu in 1987 to that in 1990?
Offer a terse response. 13.26. What is the ratio of the Aid flow (current US$) in Dominica in 1987 to that in 1991?
Your answer should be compact. 0.58. What is the ratio of the Aid flow (current US$) of Ghana in 1987 to that in 1991?
Offer a terse response. 0.51. What is the ratio of the Aid flow (current US$) in Mauritania in 1987 to that in 1991?
Your response must be concise. 0.58. What is the ratio of the Aid flow (current US$) of Tuvalu in 1987 to that in 1991?
Provide a short and direct response. 14.23. What is the ratio of the Aid flow (current US$) in Dominica in 1987 to that in 1992?
Your response must be concise. 0.28. What is the ratio of the Aid flow (current US$) in Ghana in 1987 to that in 1992?
Your answer should be very brief. 0.5. What is the ratio of the Aid flow (current US$) in Mauritania in 1987 to that in 1992?
Keep it short and to the point. 1.38. What is the ratio of the Aid flow (current US$) of Tuvalu in 1987 to that in 1992?
Ensure brevity in your answer.  27.14. What is the ratio of the Aid flow (current US$) in Dominica in 1987 to that in 1993?
Keep it short and to the point. 0.34. What is the ratio of the Aid flow (current US$) in Ghana in 1987 to that in 1993?
Offer a very short reply. 0.75. What is the ratio of the Aid flow (current US$) in Mauritania in 1987 to that in 1993?
Your response must be concise. 1.45. What is the ratio of the Aid flow (current US$) of Tuvalu in 1987 to that in 1993?
Provide a short and direct response. 116.7. What is the ratio of the Aid flow (current US$) of Dominica in 1988 to that in 1989?
Your answer should be very brief. 0.86. What is the ratio of the Aid flow (current US$) of Ghana in 1988 to that in 1989?
Offer a very short reply. 0.69. What is the ratio of the Aid flow (current US$) of Mauritania in 1988 to that in 1989?
Your response must be concise. 1.32. What is the ratio of the Aid flow (current US$) in Tuvalu in 1988 to that in 1989?
Your answer should be compact. 17.38. What is the ratio of the Aid flow (current US$) of Dominica in 1988 to that in 1990?
Make the answer very short. 1.63. What is the ratio of the Aid flow (current US$) of Ghana in 1988 to that in 1990?
Your answer should be compact. 2.24. What is the ratio of the Aid flow (current US$) in Mauritania in 1988 to that in 1990?
Ensure brevity in your answer.  2.75. What is the ratio of the Aid flow (current US$) in Tuvalu in 1988 to that in 1990?
Make the answer very short. 11.45. What is the ratio of the Aid flow (current US$) of Dominica in 1988 to that in 1991?
Give a very brief answer. 1.48. What is the ratio of the Aid flow (current US$) in Ghana in 1988 to that in 1991?
Offer a very short reply. 0.93. What is the ratio of the Aid flow (current US$) in Mauritania in 1988 to that in 1991?
Your answer should be compact. 0.66. What is the ratio of the Aid flow (current US$) of Tuvalu in 1988 to that in 1991?
Keep it short and to the point. 12.29. What is the ratio of the Aid flow (current US$) in Dominica in 1988 to that in 1992?
Provide a short and direct response. 0.73. What is the ratio of the Aid flow (current US$) of Ghana in 1988 to that in 1992?
Provide a short and direct response. 0.9. What is the ratio of the Aid flow (current US$) in Mauritania in 1988 to that in 1992?
Make the answer very short. 1.57. What is the ratio of the Aid flow (current US$) in Tuvalu in 1988 to that in 1992?
Your answer should be compact. 23.44. What is the ratio of the Aid flow (current US$) in Dominica in 1988 to that in 1993?
Your answer should be very brief. 0.89. What is the ratio of the Aid flow (current US$) of Ghana in 1988 to that in 1993?
Your answer should be compact. 1.35. What is the ratio of the Aid flow (current US$) in Mauritania in 1988 to that in 1993?
Keep it short and to the point. 1.65. What is the ratio of the Aid flow (current US$) in Tuvalu in 1988 to that in 1993?
Make the answer very short. 100.8. What is the ratio of the Aid flow (current US$) of Dominica in 1989 to that in 1990?
Offer a terse response. 1.89. What is the ratio of the Aid flow (current US$) in Ghana in 1989 to that in 1990?
Provide a succinct answer. 3.23. What is the ratio of the Aid flow (current US$) in Mauritania in 1989 to that in 1990?
Offer a very short reply. 2.08. What is the ratio of the Aid flow (current US$) of Tuvalu in 1989 to that in 1990?
Your answer should be very brief. 0.66. What is the ratio of the Aid flow (current US$) in Dominica in 1989 to that in 1991?
Give a very brief answer. 1.73. What is the ratio of the Aid flow (current US$) of Ghana in 1989 to that in 1991?
Offer a terse response. 1.34. What is the ratio of the Aid flow (current US$) of Mauritania in 1989 to that in 1991?
Make the answer very short. 0.5. What is the ratio of the Aid flow (current US$) of Tuvalu in 1989 to that in 1991?
Ensure brevity in your answer.  0.71. What is the ratio of the Aid flow (current US$) of Dominica in 1989 to that in 1992?
Keep it short and to the point. 0.85. What is the ratio of the Aid flow (current US$) of Ghana in 1989 to that in 1992?
Provide a short and direct response. 1.29. What is the ratio of the Aid flow (current US$) in Mauritania in 1989 to that in 1992?
Give a very brief answer. 1.19. What is the ratio of the Aid flow (current US$) in Tuvalu in 1989 to that in 1992?
Offer a very short reply. 1.35. What is the ratio of the Aid flow (current US$) in Dominica in 1989 to that in 1993?
Make the answer very short. 1.03. What is the ratio of the Aid flow (current US$) in Ghana in 1989 to that in 1993?
Provide a short and direct response. 1.95. What is the ratio of the Aid flow (current US$) in Mauritania in 1989 to that in 1993?
Offer a very short reply. 1.25. What is the ratio of the Aid flow (current US$) in Dominica in 1990 to that in 1991?
Keep it short and to the point. 0.91. What is the ratio of the Aid flow (current US$) in Ghana in 1990 to that in 1991?
Your answer should be very brief. 0.41. What is the ratio of the Aid flow (current US$) of Mauritania in 1990 to that in 1991?
Provide a succinct answer. 0.24. What is the ratio of the Aid flow (current US$) in Tuvalu in 1990 to that in 1991?
Your answer should be compact. 1.07. What is the ratio of the Aid flow (current US$) in Dominica in 1990 to that in 1992?
Provide a succinct answer. 0.45. What is the ratio of the Aid flow (current US$) of Ghana in 1990 to that in 1992?
Provide a short and direct response. 0.4. What is the ratio of the Aid flow (current US$) of Mauritania in 1990 to that in 1992?
Offer a terse response. 0.57. What is the ratio of the Aid flow (current US$) of Tuvalu in 1990 to that in 1992?
Provide a succinct answer. 2.05. What is the ratio of the Aid flow (current US$) of Dominica in 1990 to that in 1993?
Offer a terse response. 0.55. What is the ratio of the Aid flow (current US$) in Ghana in 1990 to that in 1993?
Give a very brief answer. 0.6. What is the ratio of the Aid flow (current US$) in Tuvalu in 1990 to that in 1993?
Your answer should be compact. 8.8. What is the ratio of the Aid flow (current US$) in Dominica in 1991 to that in 1992?
Give a very brief answer. 0.49. What is the ratio of the Aid flow (current US$) of Ghana in 1991 to that in 1992?
Your answer should be compact. 0.97. What is the ratio of the Aid flow (current US$) in Mauritania in 1991 to that in 1992?
Ensure brevity in your answer.  2.38. What is the ratio of the Aid flow (current US$) of Tuvalu in 1991 to that in 1992?
Make the answer very short. 1.91. What is the ratio of the Aid flow (current US$) in Dominica in 1991 to that in 1993?
Offer a terse response. 0.6. What is the ratio of the Aid flow (current US$) of Ghana in 1991 to that in 1993?
Make the answer very short. 1.46. What is the ratio of the Aid flow (current US$) of Tuvalu in 1991 to that in 1993?
Provide a short and direct response. 8.2. What is the ratio of the Aid flow (current US$) of Dominica in 1992 to that in 1993?
Your answer should be very brief. 1.21. What is the ratio of the Aid flow (current US$) of Ghana in 1992 to that in 1993?
Ensure brevity in your answer.  1.5. What is the ratio of the Aid flow (current US$) in Mauritania in 1992 to that in 1993?
Your answer should be compact. 1.05. What is the difference between the highest and the second highest Aid flow (current US$) in Dominica?
Provide a succinct answer. 6.80e+05. What is the difference between the highest and the second highest Aid flow (current US$) in Ghana?
Give a very brief answer. 1.63e+07. What is the difference between the highest and the second highest Aid flow (current US$) in Tuvalu?
Offer a terse response. 1.59e+06. What is the difference between the highest and the lowest Aid flow (current US$) of Dominica?
Offer a terse response. 3.34e+06. What is the difference between the highest and the lowest Aid flow (current US$) in Ghana?
Make the answer very short. 4.96e+07. What is the difference between the highest and the lowest Aid flow (current US$) in Mauritania?
Offer a very short reply. 3.80e+05. What is the difference between the highest and the lowest Aid flow (current US$) in Tuvalu?
Make the answer very short. 1.16e+07. 